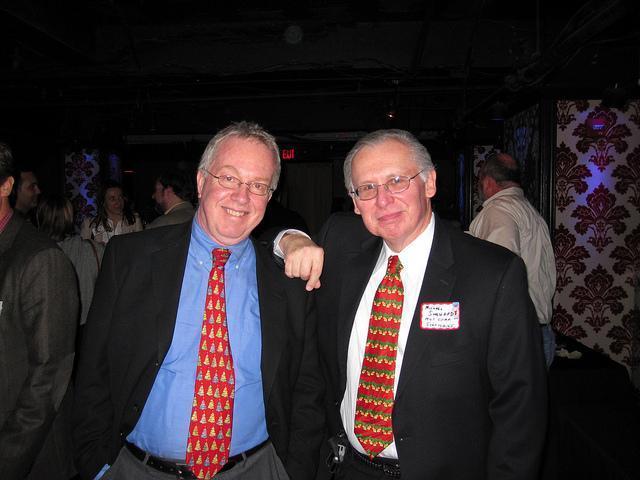How many ties are there?
Give a very brief answer. 2. How many people are visible?
Give a very brief answer. 7. 